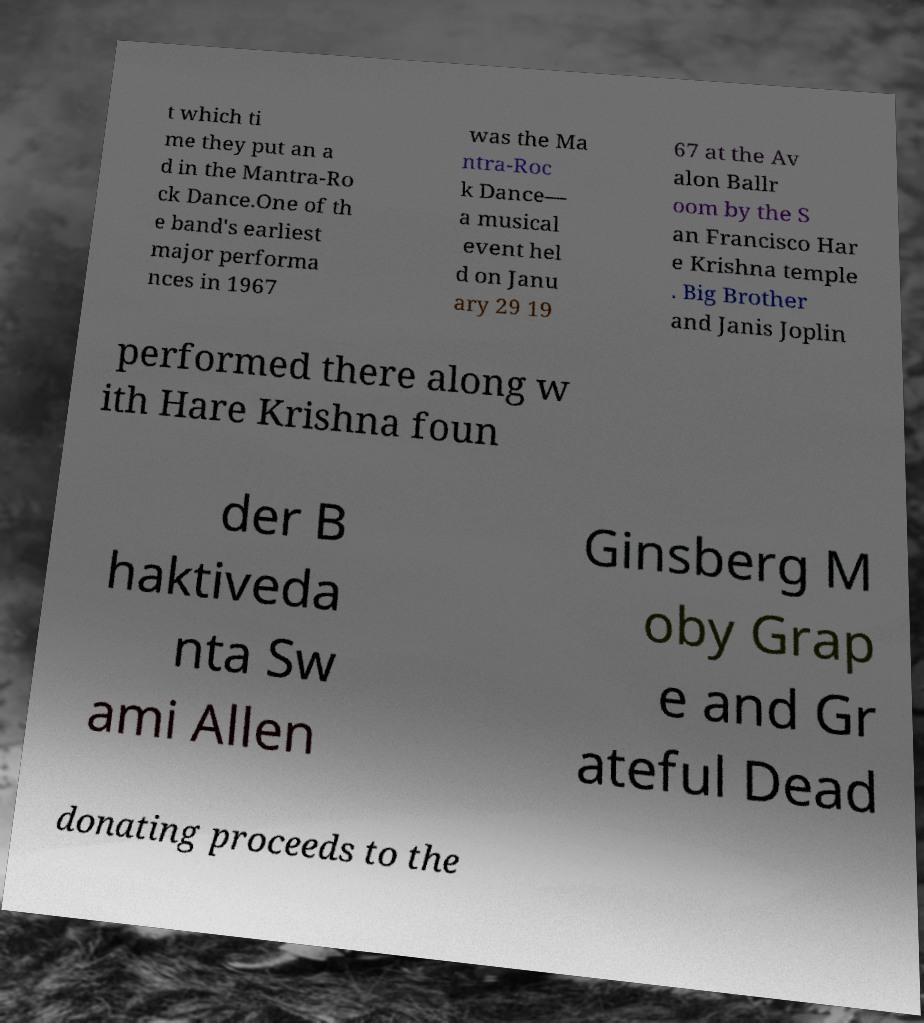Could you extract and type out the text from this image? t which ti me they put an a d in the Mantra-Ro ck Dance.One of th e band's earliest major performa nces in 1967 was the Ma ntra-Roc k Dance— a musical event hel d on Janu ary 29 19 67 at the Av alon Ballr oom by the S an Francisco Har e Krishna temple . Big Brother and Janis Joplin performed there along w ith Hare Krishna foun der B haktiveda nta Sw ami Allen Ginsberg M oby Grap e and Gr ateful Dead donating proceeds to the 